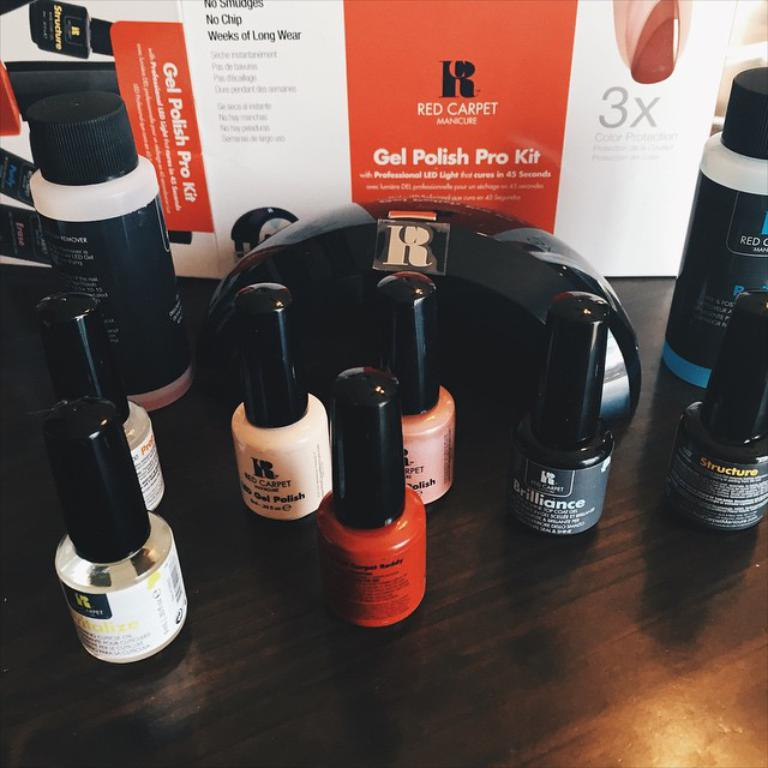<image>
Create a compact narrative representing the image presented. The product being features on the table is nail polish from the Red Carpet Gel Polish Pro Kit. 